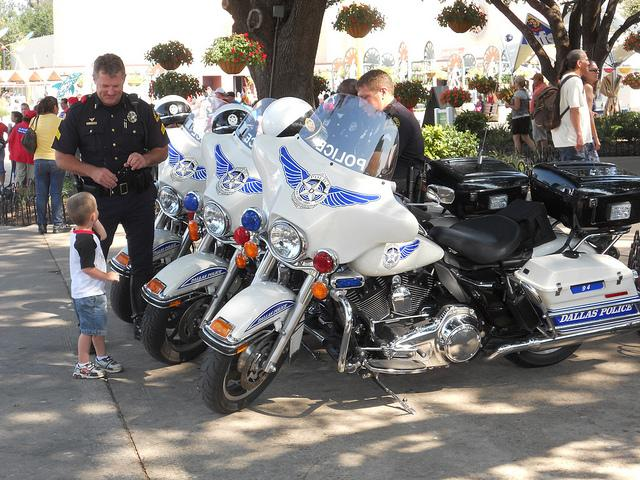What NFL team plays in the town?

Choices:
A) chiefs
B) texans
C) patriots
D) cowboys cowboys 